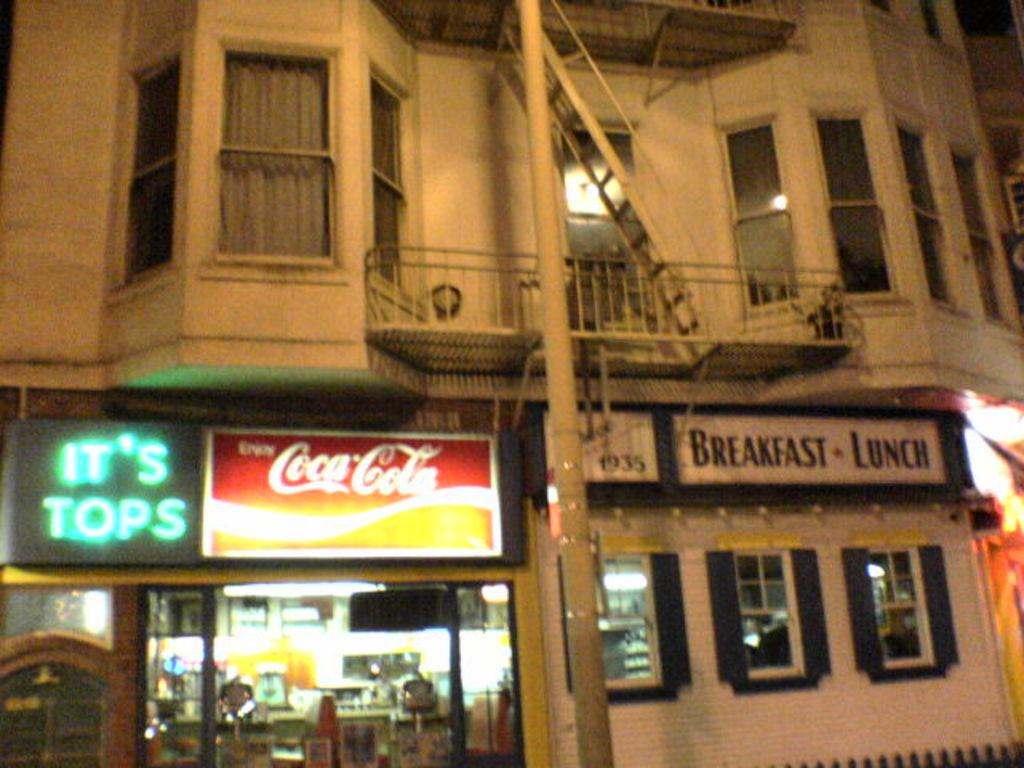What time of day was the image taken? The image was taken during night time. What is the main subject of the image? There is an outside view of a building in the image. Are there any signs or messages visible in the image? Yes, there are boards with text in the image. What other objects can be seen in the image? A pole is visible in the image. How many women are present in the image? There are no women present in the image. What question is being asked on the boards with text? The boards with text in the image do not contain any questions; they display messages or information. 